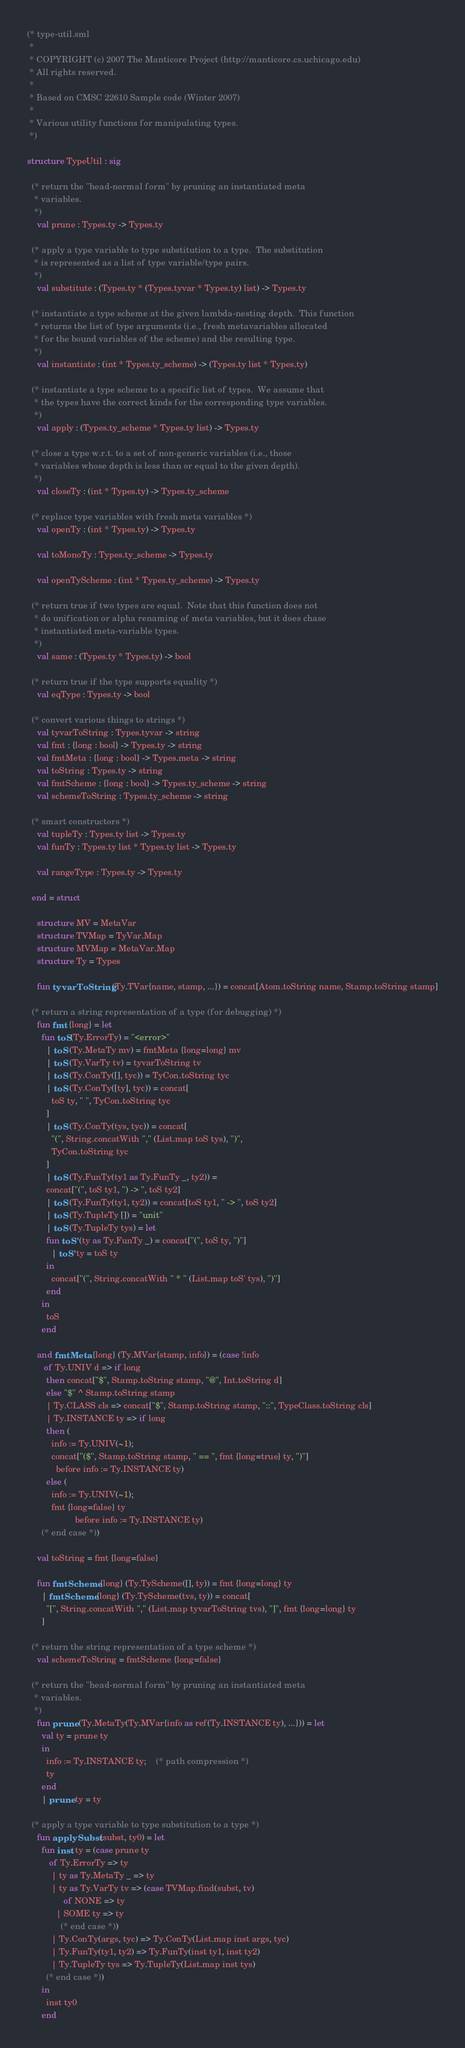Convert code to text. <code><loc_0><loc_0><loc_500><loc_500><_SML_>(* type-util.sml
 *
 * COPYRIGHT (c) 2007 The Manticore Project (http://manticore.cs.uchicago.edu)
 * All rights reserved.
 *
 * Based on CMSC 22610 Sample code (Winter 2007)
 *
 * Various utility functions for manipulating types.
 *)

structure TypeUtil : sig

  (* return the "head-normal form" by pruning an instantiated meta
   * variables.
   *)
    val prune : Types.ty -> Types.ty

  (* apply a type variable to type substitution to a type.  The substitution
   * is represented as a list of type variable/type pairs.
   *)
    val substitute : (Types.ty * (Types.tyvar * Types.ty) list) -> Types.ty

  (* instantiate a type scheme at the given lambda-nesting depth.  This function
   * returns the list of type arguments (i.e., fresh metavariables allocated
   * for the bound variables of the scheme) and the resulting type.
   *)
    val instantiate : (int * Types.ty_scheme) -> (Types.ty list * Types.ty)

  (* instantiate a type scheme to a specific list of types.  We assume that
   * the types have the correct kinds for the corresponding type variables.
   *)
    val apply : (Types.ty_scheme * Types.ty list) -> Types.ty

  (* close a type w.r.t. to a set of non-generic variables (i.e., those
   * variables whose depth is less than or equal to the given depth).
   *)
    val closeTy : (int * Types.ty) -> Types.ty_scheme

  (* replace type variables with fresh meta variables *)
    val openTy : (int * Types.ty) -> Types.ty

    val toMonoTy : Types.ty_scheme -> Types.ty

    val openTyScheme : (int * Types.ty_scheme) -> Types.ty

  (* return true if two types are equal.  Note that this function does not
   * do unification or alpha renaming of meta variables, but it does chase
   * instantiated meta-variable types.
   *)
    val same : (Types.ty * Types.ty) -> bool

  (* return true if the type supports equality *)
    val eqType : Types.ty -> bool

  (* convert various things to strings *)
    val tyvarToString : Types.tyvar -> string
    val fmt : {long : bool} -> Types.ty -> string
    val fmtMeta : {long : bool} -> Types.meta -> string
    val toString : Types.ty -> string
    val fmtScheme : {long : bool} -> Types.ty_scheme -> string
    val schemeToString : Types.ty_scheme -> string

  (* smart constructors *)
    val tupleTy : Types.ty list -> Types.ty
    val funTy : Types.ty list * Types.ty list -> Types.ty

    val rangeType : Types.ty -> Types.ty

  end = struct

    structure MV = MetaVar
    structure TVMap = TyVar.Map
    structure MVMap = MetaVar.Map
    structure Ty = Types

    fun tyvarToString (Ty.TVar{name, stamp, ...}) = concat[Atom.toString name, Stamp.toString stamp]

  (* return a string representation of a type (for debugging) *)
    fun fmt {long} = let
	  fun toS(Ty.ErrorTy) = "<error>"
	    | toS (Ty.MetaTy mv) = fmtMeta {long=long} mv
	    | toS (Ty.VarTy tv) = tyvarToString tv
	    | toS (Ty.ConTy([], tyc)) = TyCon.toString tyc
	    | toS (Ty.ConTy([ty], tyc)) = concat[
		  toS ty, " ", TyCon.toString tyc
		]
	    | toS (Ty.ConTy(tys, tyc)) = concat[
		  "(", String.concatWith "," (List.map toS tys), ")",
		  TyCon.toString tyc
		]
	    | toS (Ty.FunTy(ty1 as Ty.FunTy _, ty2)) =
		concat["(", toS ty1, ") -> ", toS ty2]
	    | toS (Ty.FunTy(ty1, ty2)) = concat[toS ty1, " -> ", toS ty2]
	    | toS (Ty.TupleTy []) = "unit"
	    | toS (Ty.TupleTy tys) = let
		fun toS' (ty as Ty.FunTy _) = concat["(", toS ty, ")"]
		  | toS' ty = toS ty
		in
		  concat["(", String.concatWith " * " (List.map toS' tys), ")"]
		end
	  in
	    toS
	  end

    and fmtMeta {long} (Ty.MVar{stamp, info}) = (case !info
	   of Ty.UNIV d => if long
		then concat["$", Stamp.toString stamp, "@", Int.toString d]
		else "$" ^ Stamp.toString stamp
	    | Ty.CLASS cls => concat["$", Stamp.toString stamp, "::", TypeClass.toString cls]
	    | Ty.INSTANCE ty => if long
		then (
		  info := Ty.UNIV(~1);
		  concat["($", Stamp.toString stamp, " == ", fmt {long=true} ty, ")"]
		    before info := Ty.INSTANCE ty)
		else (
		  info := Ty.UNIV(~1);
		  fmt {long=false} ty
                    before info := Ty.INSTANCE ty)
	  (* end case *))

    val toString = fmt {long=false}

    fun fmtScheme {long} (Ty.TyScheme([], ty)) = fmt {long=long} ty
      | fmtScheme {long} (Ty.TyScheme(tvs, ty)) = concat[
	    "[", String.concatWith "," (List.map tyvarToString tvs), "]", fmt {long=long} ty
	  ]

  (* return the string representation of a type scheme *)
    val schemeToString = fmtScheme {long=false}

  (* return the "head-normal form" by pruning an instantiated meta
   * variables.
   *)
    fun prune (Ty.MetaTy(Ty.MVar{info as ref(Ty.INSTANCE ty), ...})) = let
	  val ty = prune ty
	  in
	    info := Ty.INSTANCE ty;	(* path compression *)
	    ty
	  end
      | prune ty = ty

  (* apply a type variable to type substitution to a type *)
    fun applySubst (subst, ty0) = let
	  fun inst ty = (case prune ty
		 of Ty.ErrorTy => ty
		  | ty as Ty.MetaTy _ => ty
		  | ty as Ty.VarTy tv => (case TVMap.find(subst, tv)
		       of NONE => ty
			| SOME ty => ty
		      (* end case *))
		  | Ty.ConTy(args, tyc) => Ty.ConTy(List.map inst args, tyc)
		  | Ty.FunTy(ty1, ty2) => Ty.FunTy(inst ty1, inst ty2)
		  | Ty.TupleTy tys => Ty.TupleTy(List.map inst tys)
		(* end case *))
	  in
	    inst ty0
	  end
</code> 